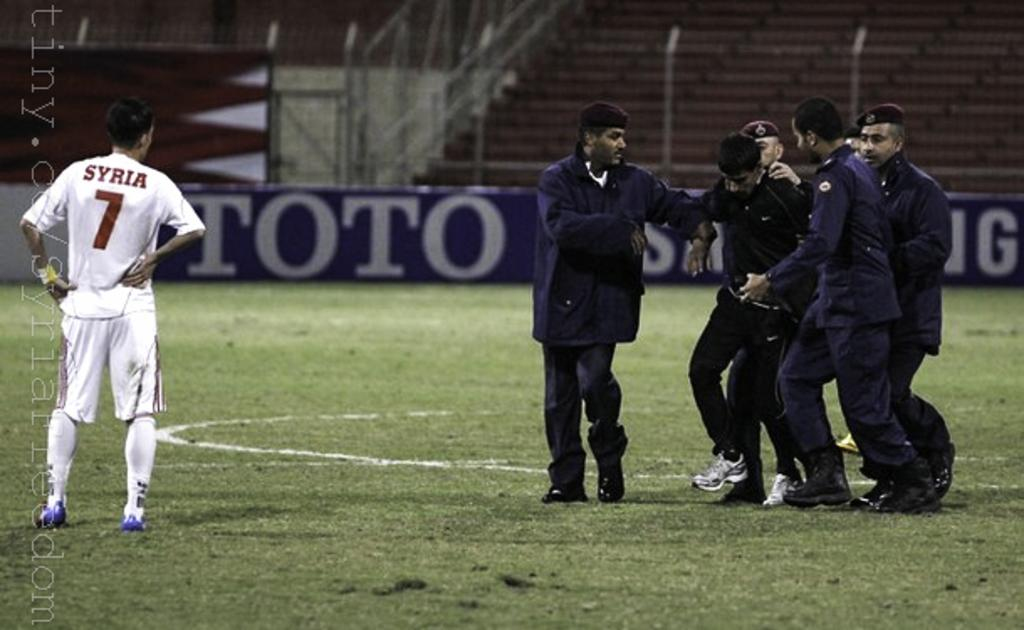<image>
Summarize the visual content of the image. a soccer player that has the number 7 on their jersey 